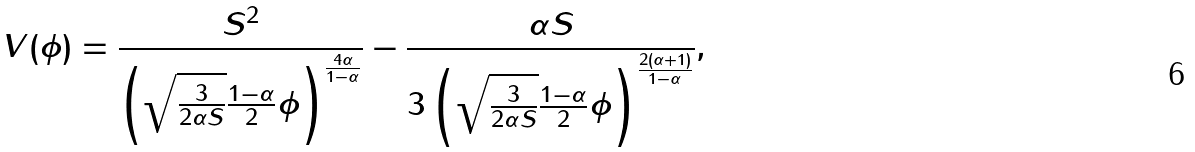<formula> <loc_0><loc_0><loc_500><loc_500>V ( \phi ) = \frac { S ^ { 2 } } { \left ( \sqrt { \frac { 3 } { 2 \alpha S } } \frac { 1 - \alpha } { 2 } \phi \right ) ^ { \frac { 4 \alpha } { 1 - \alpha } } } - \frac { \alpha S } { 3 \left ( \sqrt { \frac { 3 } { 2 \alpha S } } \frac { 1 - \alpha } { 2 } \phi \right ) ^ { \frac { 2 ( \alpha + 1 ) } { 1 - \alpha } } } ,</formula> 